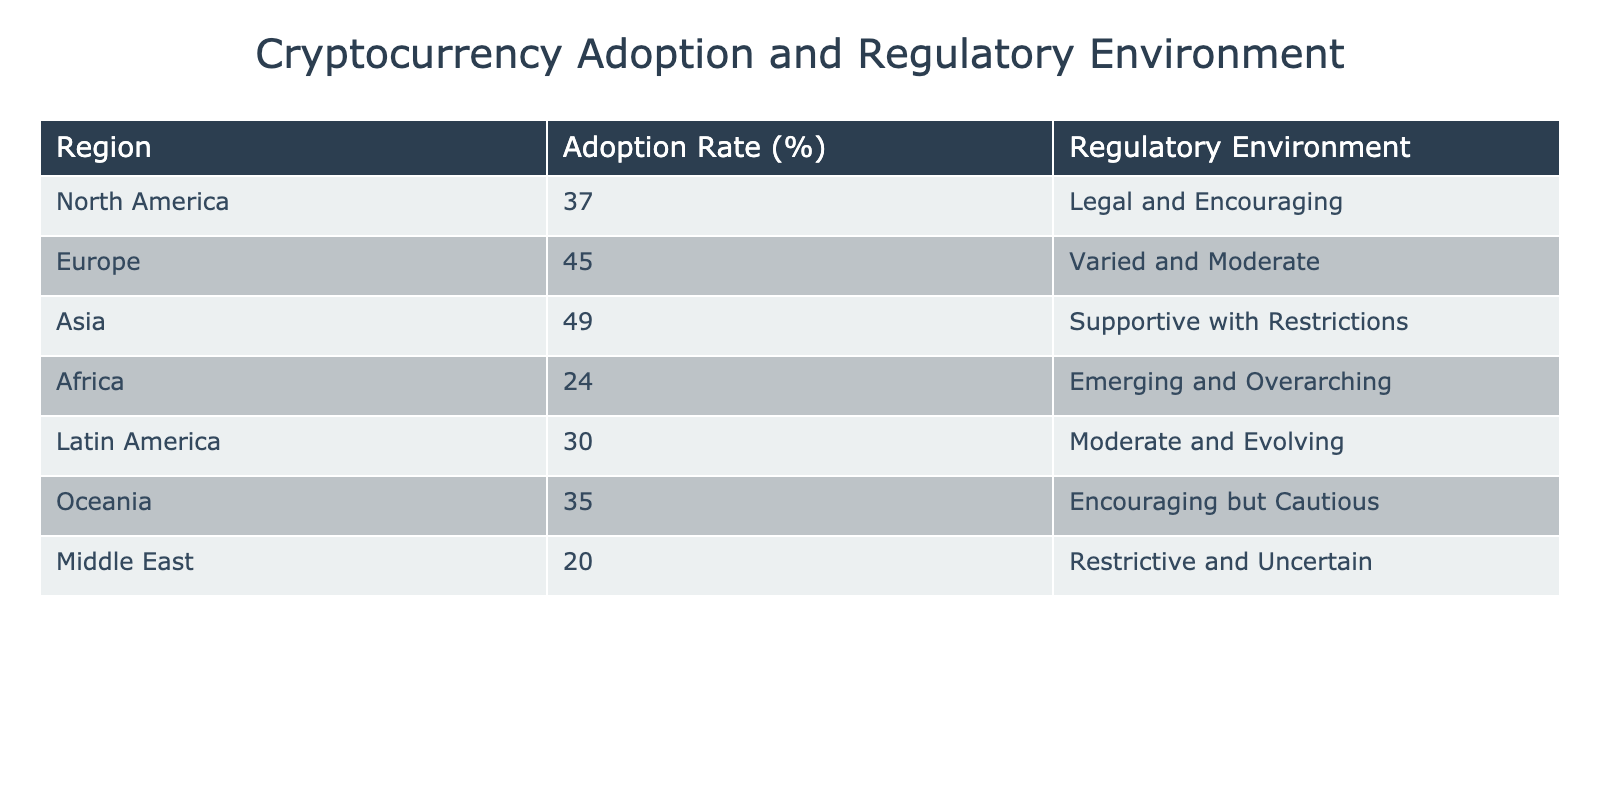What is the adoption rate in Europe? According to the table, the adoption rate for Europe is directly stated as 45%.
Answer: 45 Which region has the highest adoption rate? From the table, Asia has the highest adoption rate listed, which is 49%.
Answer: Asia Is the regulatory environment in North America considered encouraging? The table specifies that the regulatory environment in North America is "Legal and Encouraging," which confirms that it is indeed encouraging.
Answer: Yes What is the average adoption rate across all regions? To calculate the average, add all the adoption rates: (37 + 45 + 49 + 24 + 30 + 35 + 20) = 240. There are 7 regions, so the average is 240 / 7 = approximately 34.29.
Answer: Approximately 34.29 Is the adoption rate in Africa higher than that in Latin America? The adoption rate in Africa is 24%, while in Latin America it is 30%. Since 24 is less than 30, the statement is not true.
Answer: No Which region has the lowest adoption rate, and what is the associated regulatory environment? The table shows that the Middle East has the lowest adoption rate at 20%, with a regulatory environment described as "Restrictive and Uncertain."
Answer: The Middle East; Restrictive and Uncertain If we combine the adoption rates of North America and Latin America, what is the total? North America has an adoption rate of 37%, and Latin America has 30%. Adding these together results in a total of 37 + 30 = 67%.
Answer: 67 Is it true that all regions with a supportive regulatory environment have adoption rates above 30%? The table shows that Asia’s regulatory environment is "Supportive with Restrictions" at 49%, and Africa has a "Emerging and Overarching" setting with a 24% adoption rate, which is below 30%. Thus, the statement is false.
Answer: No 